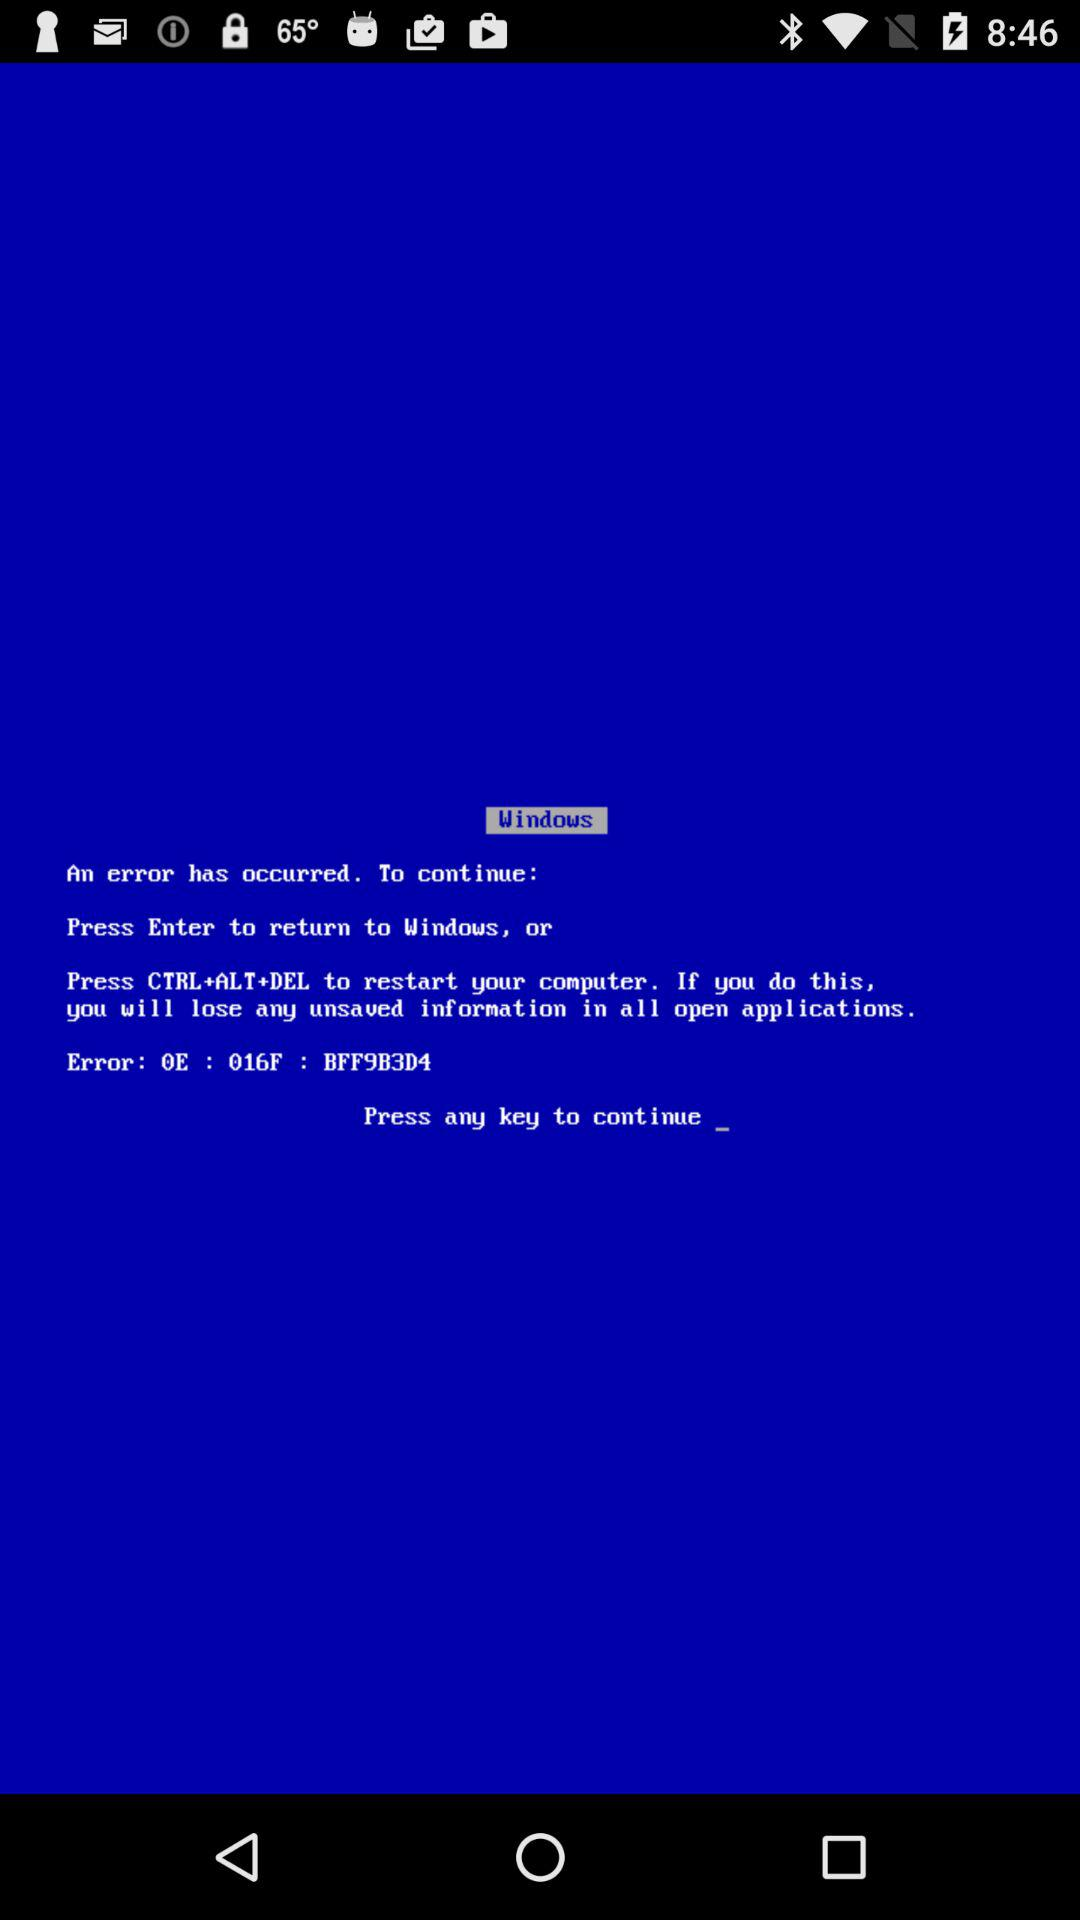What will happen if I press Enter? If you press Enter, you will return to Windows. 